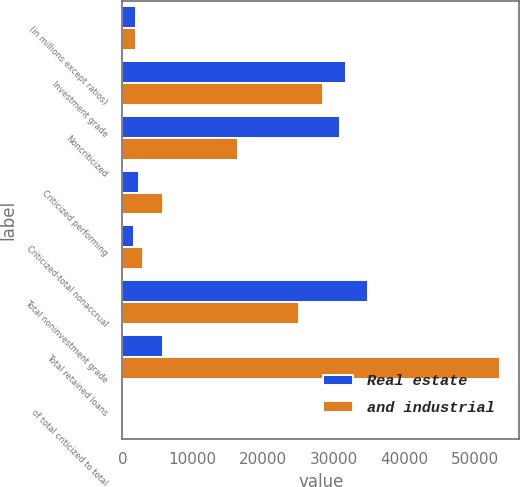Convert chart to OTSL. <chart><loc_0><loc_0><loc_500><loc_500><stacked_bar_chart><ecel><fcel>(in millions except ratios)<fcel>Investment grade<fcel>Noncriticized<fcel>Criticized performing<fcel>Criticized-total nonaccrual<fcel>Total noninvestment grade<fcel>Total retained loans<fcel>of total criticized to total<nl><fcel>Real estate<fcel>2010<fcel>31697<fcel>30874<fcel>2371<fcel>1634<fcel>34879<fcel>5769<fcel>6.02<nl><fcel>and industrial<fcel>2010<fcel>28504<fcel>16425<fcel>5769<fcel>2937<fcel>25131<fcel>53635<fcel>16.23<nl></chart> 